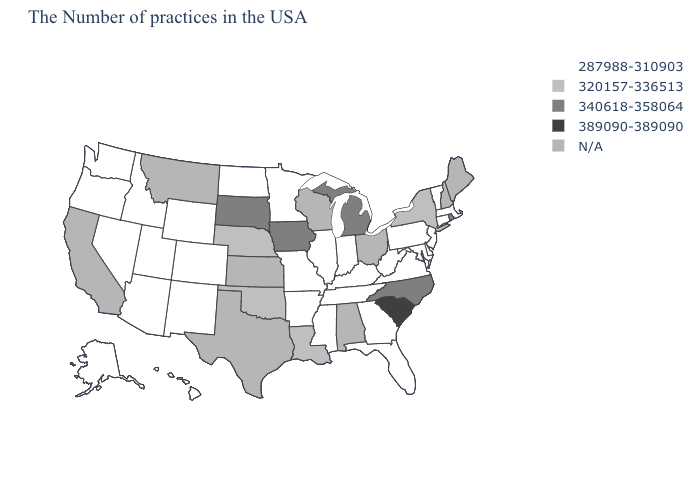What is the value of Connecticut?
Keep it brief. 287988-310903. Among the states that border Colorado , which have the lowest value?
Write a very short answer. Wyoming, New Mexico, Utah, Arizona. Does the map have missing data?
Give a very brief answer. Yes. What is the highest value in the USA?
Quick response, please. 389090-389090. Which states have the highest value in the USA?
Keep it brief. South Carolina. Name the states that have a value in the range 340618-358064?
Answer briefly. Rhode Island, North Carolina, Michigan, Iowa, South Dakota. What is the highest value in states that border Virginia?
Answer briefly. 340618-358064. Name the states that have a value in the range 287988-310903?
Keep it brief. Massachusetts, Vermont, Connecticut, New Jersey, Delaware, Maryland, Pennsylvania, Virginia, West Virginia, Florida, Georgia, Kentucky, Indiana, Tennessee, Illinois, Mississippi, Missouri, Arkansas, Minnesota, North Dakota, Wyoming, Colorado, New Mexico, Utah, Arizona, Idaho, Nevada, Washington, Oregon, Alaska, Hawaii. Does South Dakota have the highest value in the MidWest?
Keep it brief. Yes. What is the lowest value in the USA?
Give a very brief answer. 287988-310903. What is the value of Maryland?
Short answer required. 287988-310903. What is the value of Nevada?
Write a very short answer. 287988-310903. 